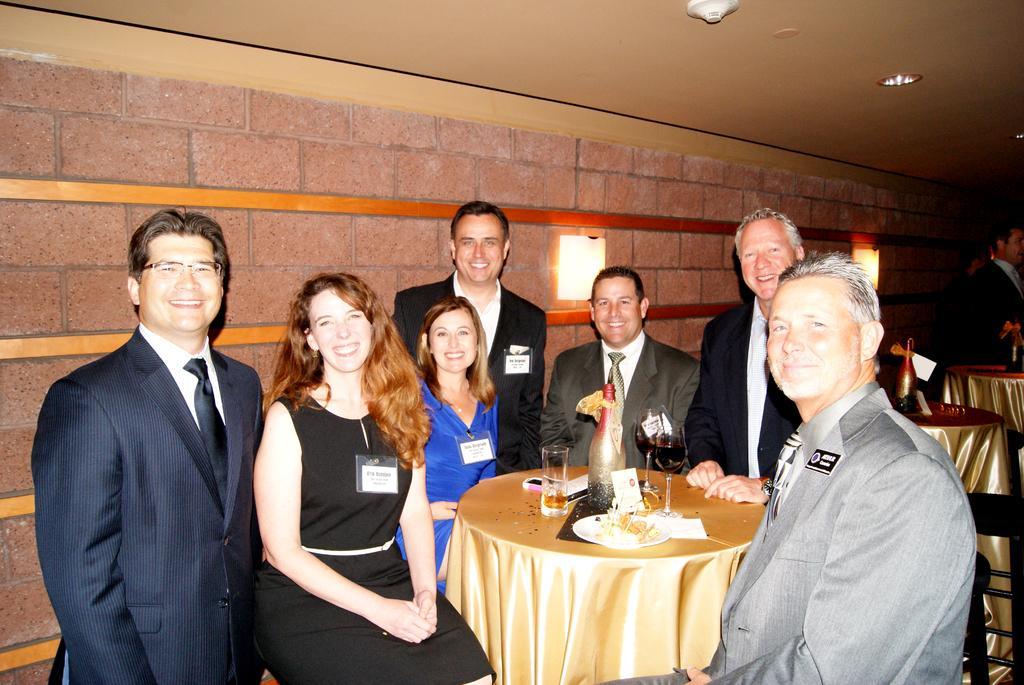In one or two sentences, can you explain what this image depicts? This group of people are highlighted in this picture. This group of people are holding a smile. On this table there is a bottle, card, plate and glasses. 